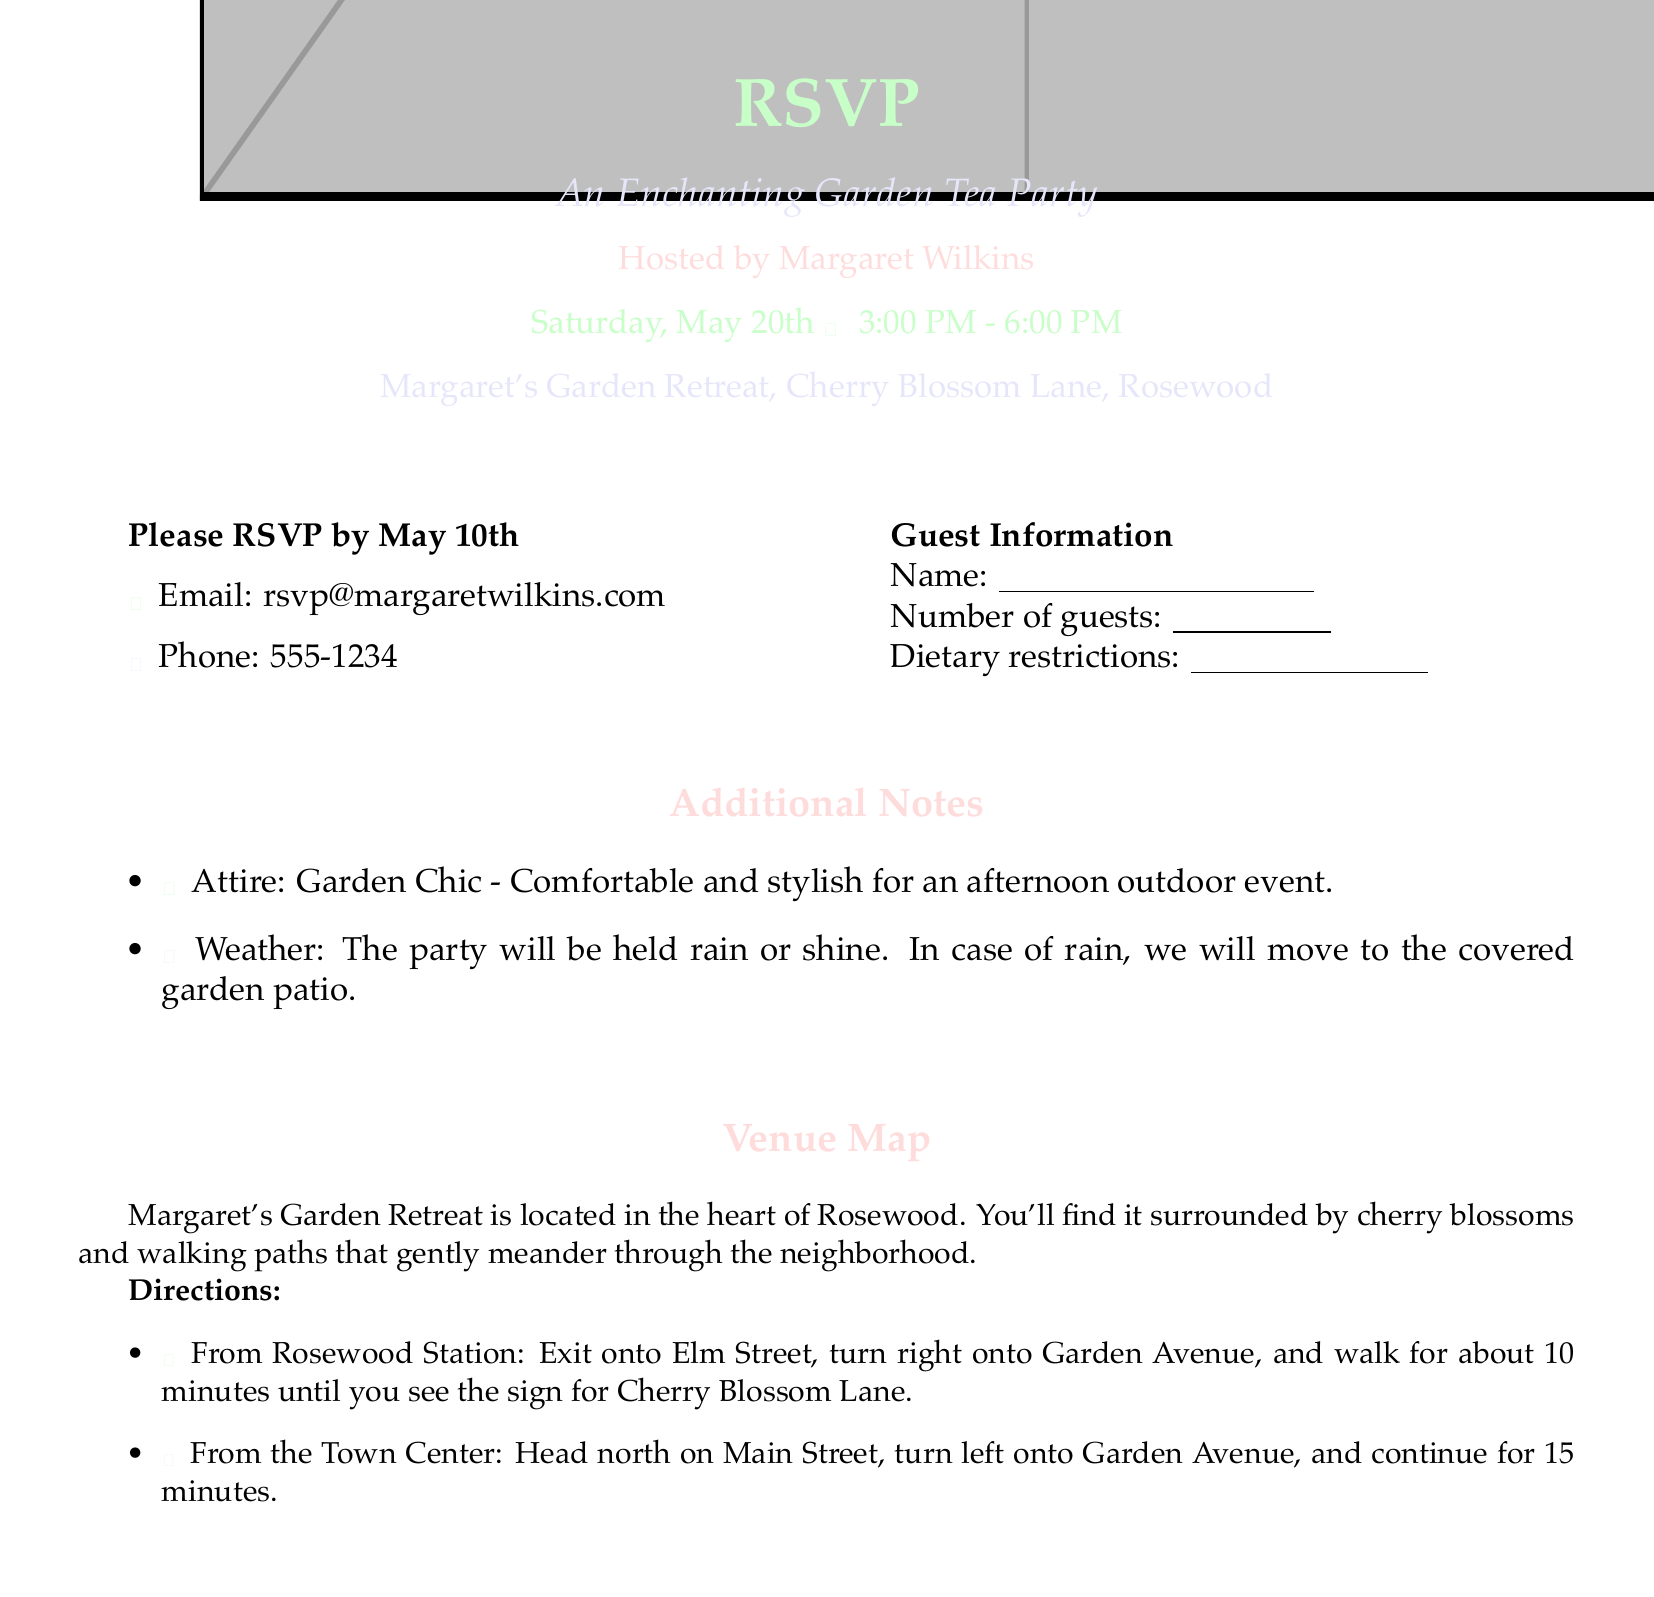What is the date of the Garden Tea Party? The document specifies that the Garden Tea Party will be held on Saturday, May 20th.
Answer: May 20th Who is hosting the event? The RSVP card mentions that the event is hosted by Margaret Wilkins.
Answer: Margaret Wilkins What time does the event start? The card states that the party will begin at 3:00 PM.
Answer: 3:00 PM What is the RSVP deadline? The document indicates that the RSVP must be made by May 10th.
Answer: May 10th How can guests RSVP by email? The RSVP card provides an email address for responses, which is rsvp@margaretwilkins.com.
Answer: rsvp@margaretwilkins.com What attire is suggested for the event? The RSVP card recommends "Garden Chic" attire for guests attending the party.
Answer: Garden Chic Where is the event taking place? The card states that the event will be held at Margaret's Garden Retreat, located on Cherry Blossom Lane, Rosewood.
Answer: Margaret's Garden Retreat What alternative plan is mentioned in case of rain? The document notes that the party will move to the covered garden patio if it rains.
Answer: Covered garden patio How long does it take to walk from Rosewood Station to the venue? The directions suggest it takes about 10 minutes to walk from Rosewood Station.
Answer: 10 minutes 